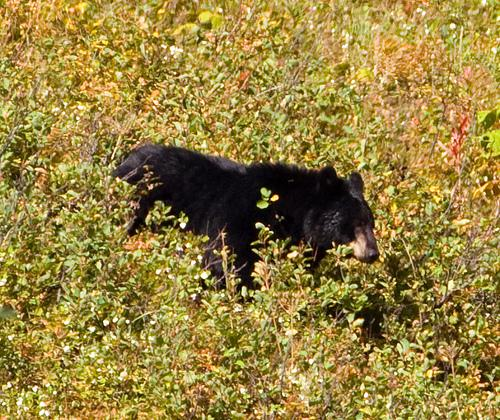Question: when will the bear leave?
Choices:
A. Tomorrow.
B. In a few minutes.
C. Soon.
D. When it has caught a fish.
Answer with the letter. Answer: C Question: what color is the bear?
Choices:
A. Black.
B. Gray.
C. Brown.
D. White.
Answer with the letter. Answer: A 